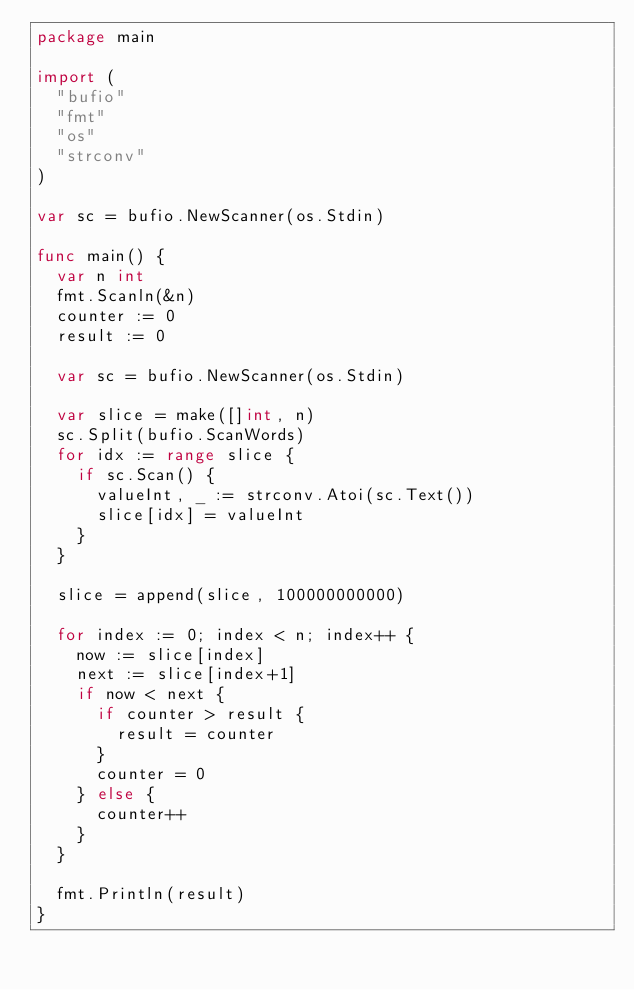<code> <loc_0><loc_0><loc_500><loc_500><_Go_>package main

import (
	"bufio"
	"fmt"
	"os"
	"strconv"
)

var sc = bufio.NewScanner(os.Stdin)

func main() {
	var n int
	fmt.Scanln(&n)
	counter := 0
	result := 0

	var sc = bufio.NewScanner(os.Stdin)

	var slice = make([]int, n)
	sc.Split(bufio.ScanWords)
	for idx := range slice {
		if sc.Scan() {
			valueInt, _ := strconv.Atoi(sc.Text())
			slice[idx] = valueInt
		}
	}

	slice = append(slice, 100000000000)

	for index := 0; index < n; index++ {
		now := slice[index]
		next := slice[index+1]
		if now < next {
			if counter > result {
				result = counter
			}
			counter = 0
		} else {
			counter++
		}
	}

	fmt.Println(result)
}
</code> 